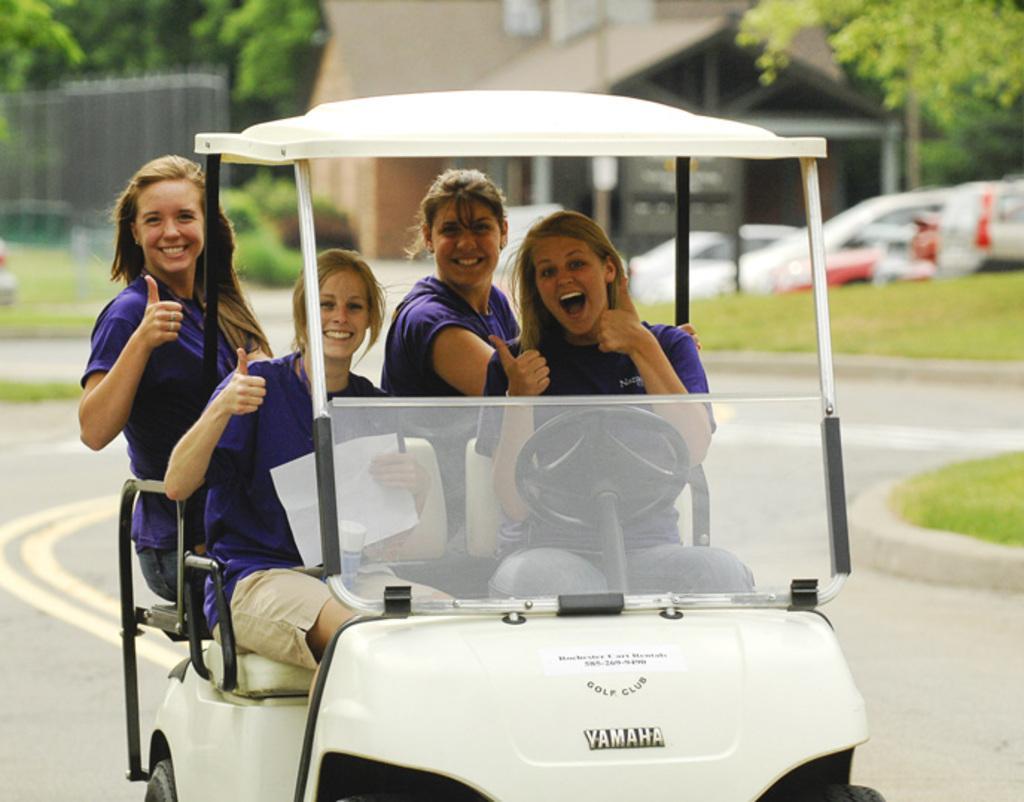Can you describe this image briefly? Four women are riding an electric vehicle on a road. 